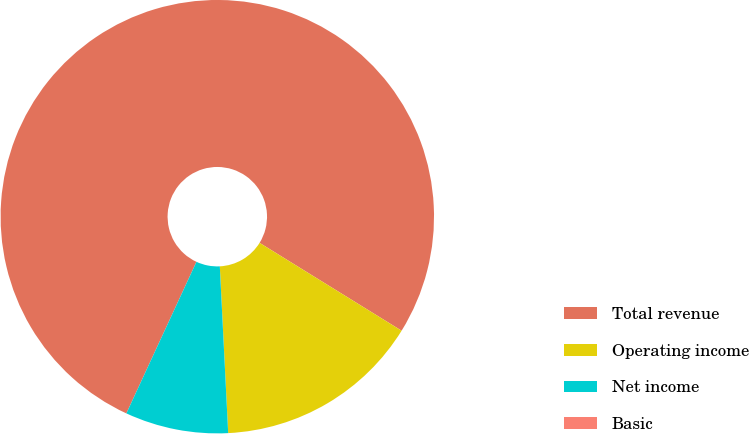Convert chart. <chart><loc_0><loc_0><loc_500><loc_500><pie_chart><fcel>Total revenue<fcel>Operating income<fcel>Net income<fcel>Basic<nl><fcel>76.92%<fcel>15.38%<fcel>7.69%<fcel>0.0%<nl></chart> 